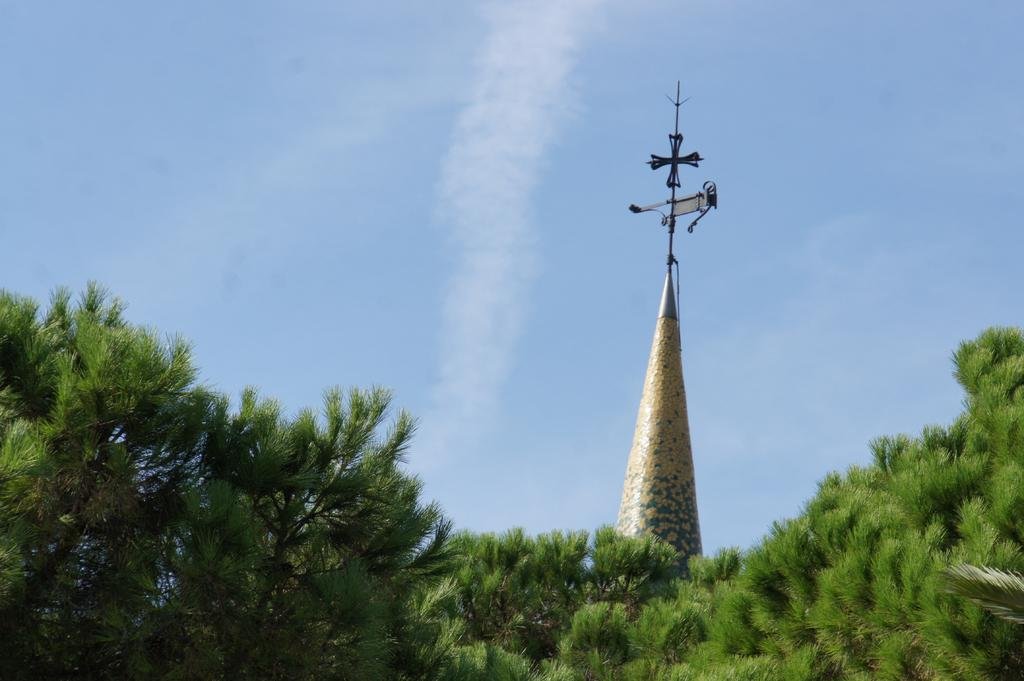What type of vegetation is present in the image? There are many trees in the image. What structure can be seen in the background of the image? There is a building with a tower in the background. What is visible at the top of the image? The sky is clear and visible at the top of the image. What type of rhythm can be heard coming from the quiver in the image? There is no quiver or rhythm present in the image. 